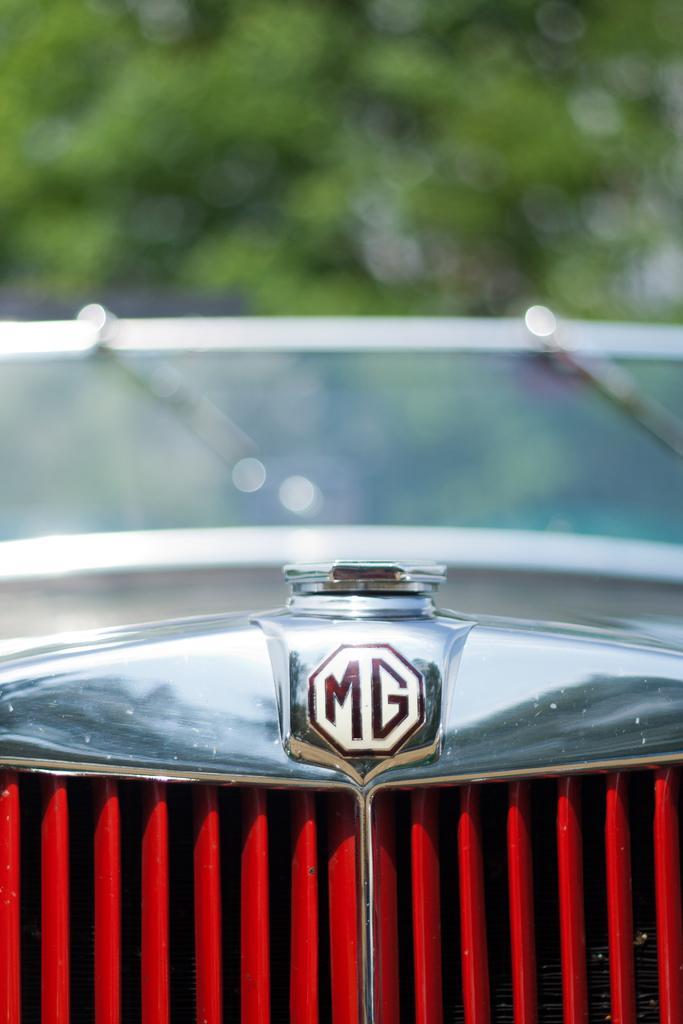In one or two sentences, can you explain what this image depicts? In this picture we can see a close view on the car radiator grill on which "MG" monogram is seen. Behind we can see green tree and blur background. 